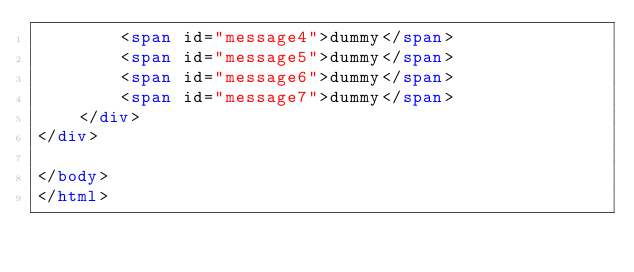Convert code to text. <code><loc_0><loc_0><loc_500><loc_500><_HTML_>        <span id="message4">dummy</span>
        <span id="message5">dummy</span>
        <span id="message6">dummy</span>
        <span id="message7">dummy</span>
    </div>
</div>

</body>
</html>
</code> 